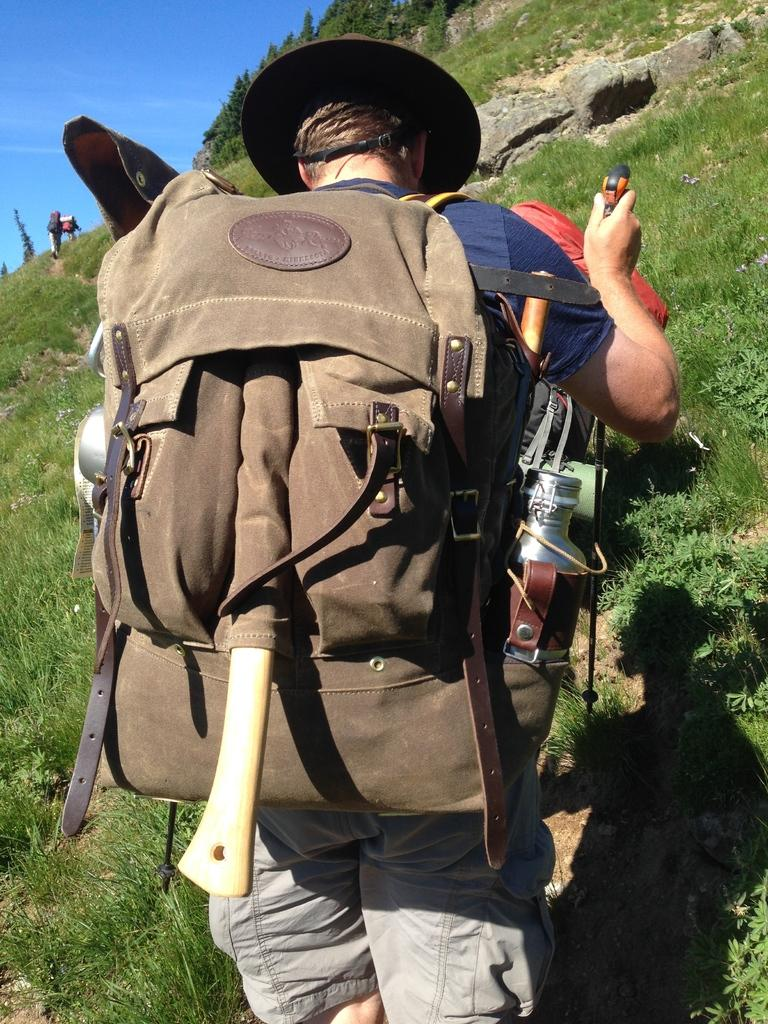Who is present in the image? There is a man in the image. What is the man wearing on his upper body? The man is wearing a blue t-shirt. What type of pants is the man wearing? The man is wearing trousers. What is the man carrying on his back? The man is carrying a backpack. What can be seen in the distance in the image? There is a hill in the background of the image. What is visible above the hill in the image? The sky is visible in the background of the image. What type of thread is being used to sew the stew in the image? There is no stew or thread present in the image; it features a man wearing a blue t-shirt, trousers, and carrying a backpack, with a hill and sky visible in the background. 